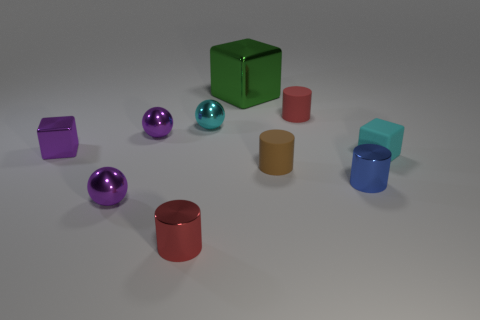There is a thing that is the same color as the matte cube; what size is it?
Make the answer very short. Small. What material is the red object that is behind the metallic cylinder that is in front of the small blue cylinder made of?
Provide a succinct answer. Rubber. Are there fewer brown matte cylinders to the right of the small blue thing than cyan things that are to the left of the tiny rubber block?
Your answer should be compact. Yes. How many brown things are either tiny rubber cylinders or matte objects?
Ensure brevity in your answer.  1. Is the number of small brown matte cylinders on the left side of the brown cylinder the same as the number of purple shiny cylinders?
Make the answer very short. Yes. How many things are small blue matte things or small metallic cylinders to the left of the large object?
Your answer should be very brief. 1. Do the big metal block and the rubber cube have the same color?
Keep it short and to the point. No. Are there any red objects that have the same material as the blue object?
Your answer should be very brief. Yes. What color is the other rubber thing that is the same shape as the red matte object?
Provide a short and direct response. Brown. Does the brown cylinder have the same material as the sphere in front of the purple block?
Ensure brevity in your answer.  No. 